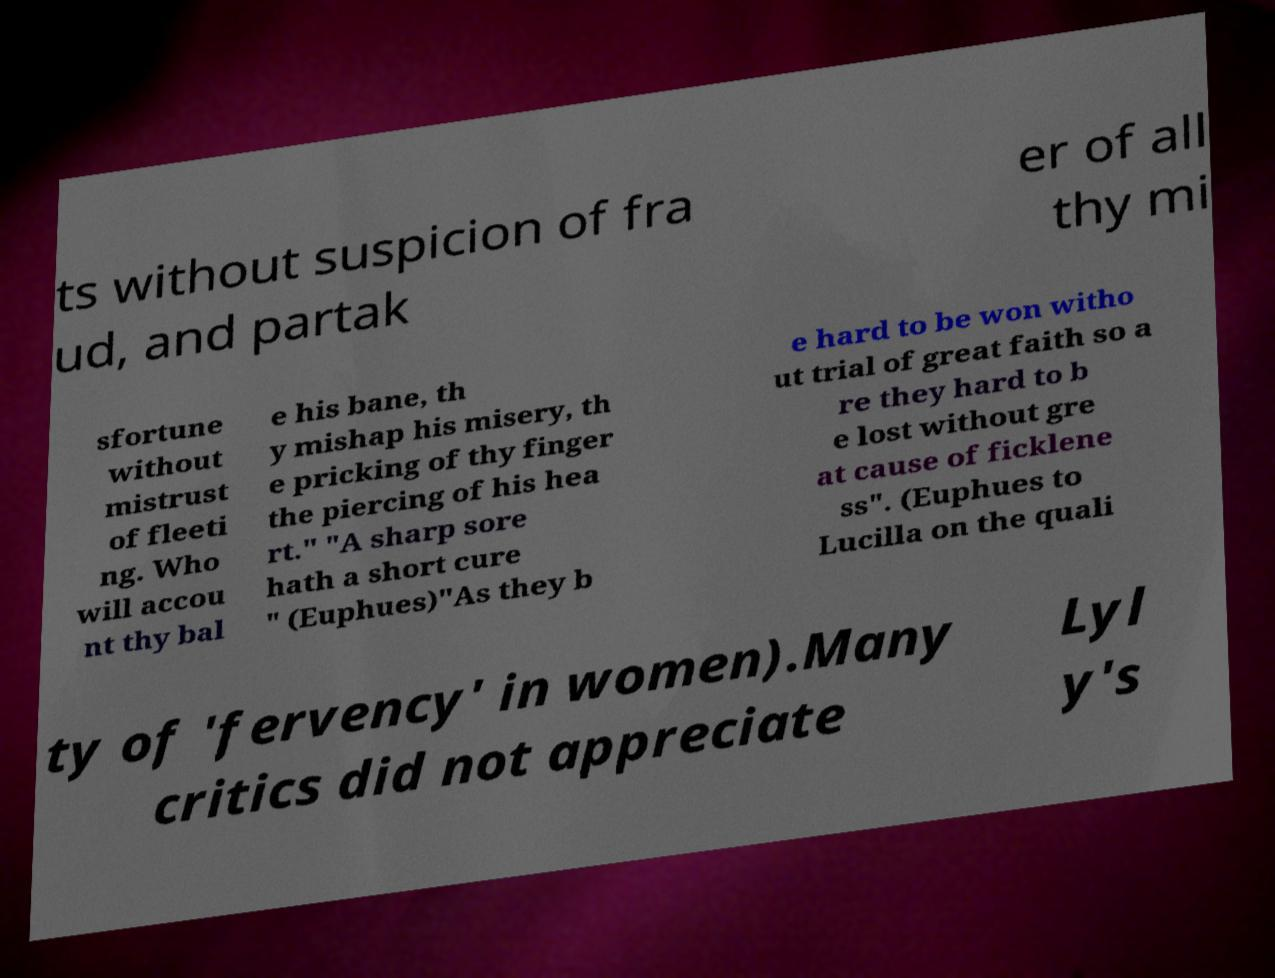Please identify and transcribe the text found in this image. ts without suspicion of fra ud, and partak er of all thy mi sfortune without mistrust of fleeti ng. Who will accou nt thy bal e his bane, th y mishap his misery, th e pricking of thy finger the piercing of his hea rt." "A sharp sore hath a short cure " (Euphues)"As they b e hard to be won witho ut trial of great faith so a re they hard to b e lost without gre at cause of ficklene ss". (Euphues to Lucilla on the quali ty of 'fervency' in women).Many critics did not appreciate Lyl y's 